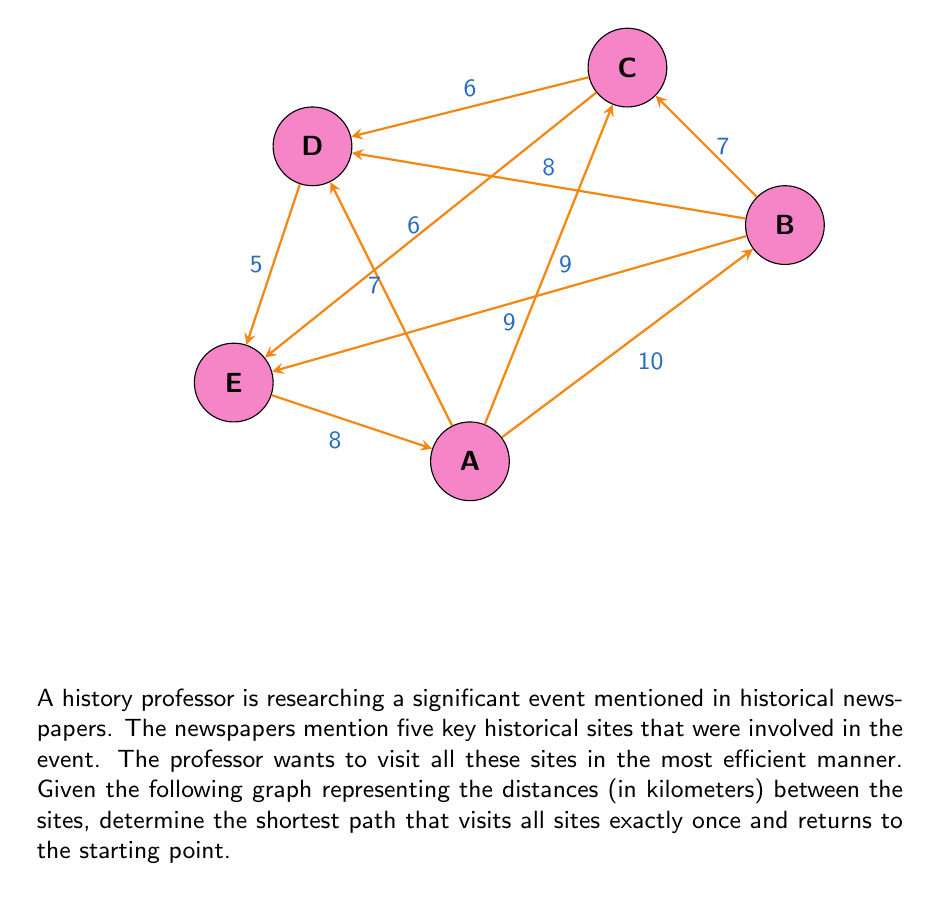What is the answer to this math problem? To solve this problem, we need to find the Hamiltonian cycle with the minimum total weight in the given graph. This is known as the Traveling Salesman Problem (TSP), which is NP-hard. For small instances like this, we can use a brute-force approach:

1) List all possible Hamiltonian cycles:
   A-B-C-D-E-A
   A-B-C-E-D-A
   A-B-D-C-E-A
   A-B-D-E-C-A
   A-B-E-C-D-A
   A-B-E-D-C-A
   (and their reverses, which have the same total distance)

2) Calculate the total distance for each cycle:
   A-B-C-D-E-A: 10 + 7 + 6 + 5 + 8 = 36 km
   A-B-C-E-D-A: 10 + 7 + 6 + 5 + 7 = 35 km
   A-B-D-C-E-A: 10 + 8 + 6 + 6 + 8 = 38 km
   A-B-D-E-C-A: 10 + 8 + 5 + 6 + 9 = 38 km
   A-B-E-C-D-A: 10 + 9 + 6 + 6 + 7 = 38 km
   A-B-E-D-C-A: 10 + 9 + 5 + 6 + 9 = 39 km

3) Identify the cycle with the minimum total distance:
   A-B-C-E-D-A with a total distance of 35 km.

Therefore, the shortest path for the history professor to visit all sites and return to the starting point is A-B-C-E-D-A, covering a total distance of 35 km.
Answer: A-B-C-E-D-A, 35 km 